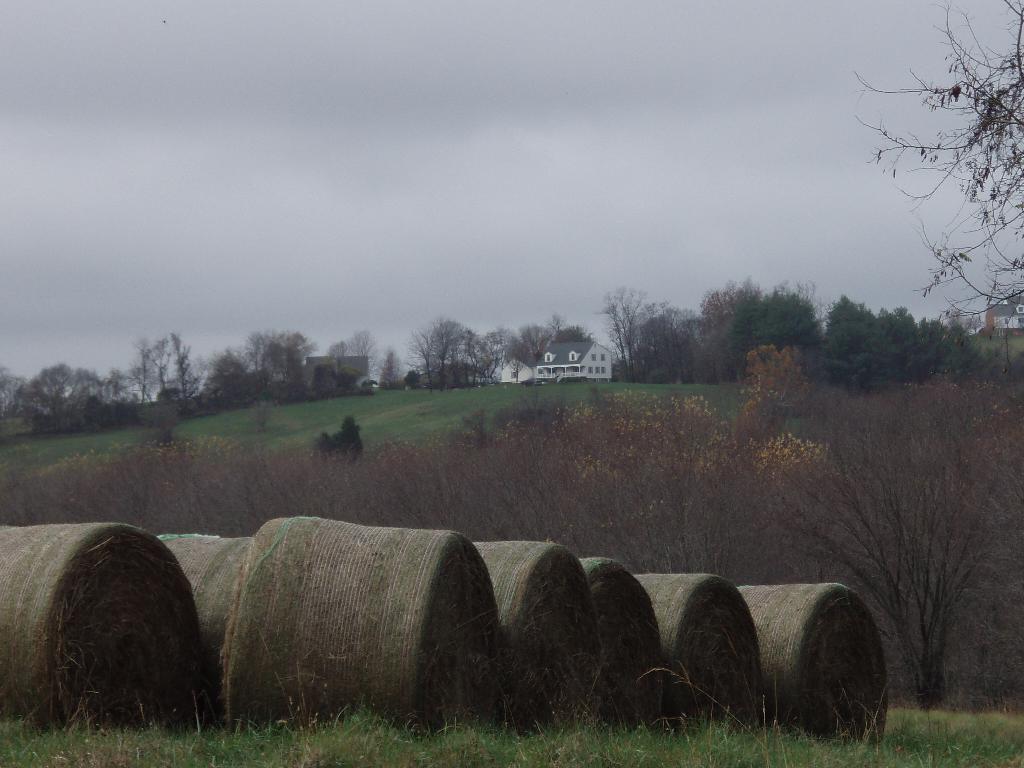In one or two sentences, can you explain what this image depicts? In this picture we can see some objects on the ground, trees, grass, buildings with windows and in the background we can see the sky with clouds. 